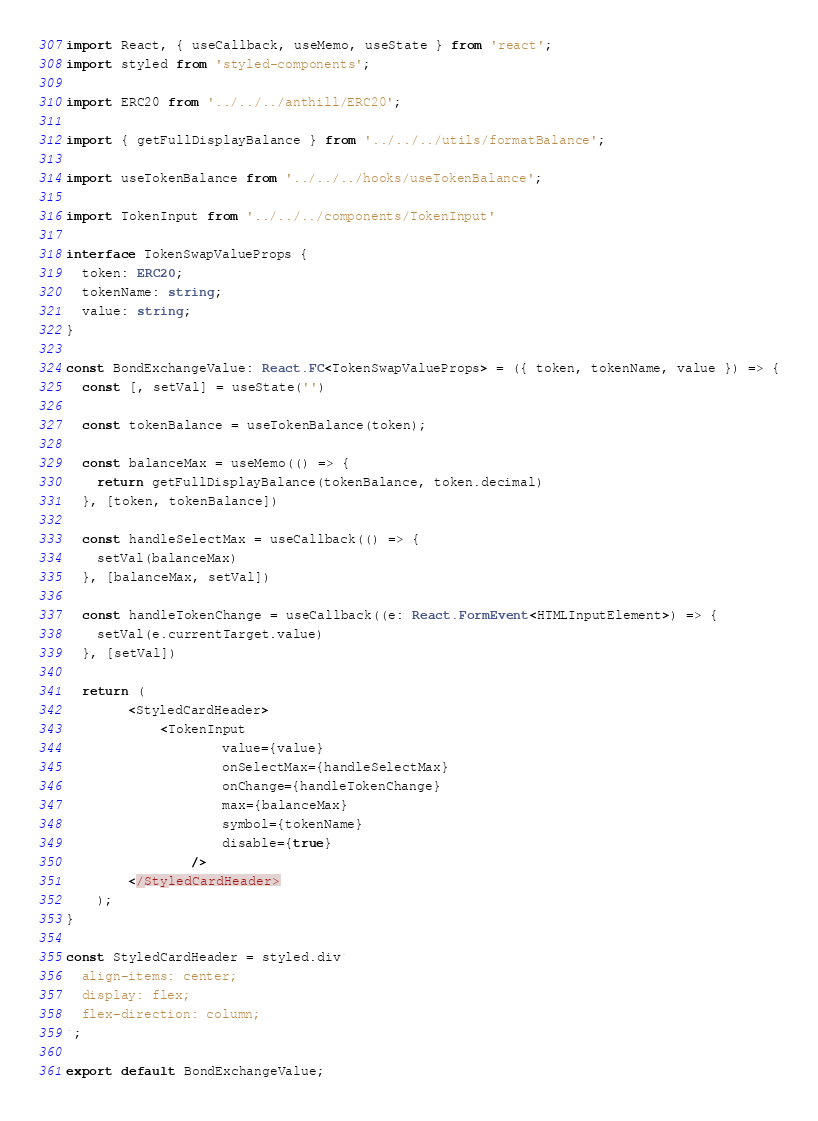<code> <loc_0><loc_0><loc_500><loc_500><_TypeScript_>import React, { useCallback, useMemo, useState } from 'react';
import styled from 'styled-components';

import ERC20 from '../../../anthill/ERC20';

import { getFullDisplayBalance } from '../../../utils/formatBalance';

import useTokenBalance from '../../../hooks/useTokenBalance';

import TokenInput from '../../../components/TokenInput'

interface TokenSwapValueProps {
  token: ERC20;
  tokenName: string;
  value: string;
}

const BondExchangeValue: React.FC<TokenSwapValueProps> = ({ token, tokenName, value }) => {
  const [, setVal] = useState('')

  const tokenBalance = useTokenBalance(token);
    
  const balanceMax = useMemo(() => {
    return getFullDisplayBalance(tokenBalance, token.decimal)
  }, [token, tokenBalance])

  const handleSelectMax = useCallback(() => {
    setVal(balanceMax)
  }, [balanceMax, setVal])

  const handleTokenChange = useCallback((e: React.FormEvent<HTMLInputElement>) => {
    setVal(e.currentTarget.value)
  }, [setVal])

  return (
        <StyledCardHeader>
            <TokenInput
                    value={value}
                    onSelectMax={handleSelectMax}
                    onChange={handleTokenChange}
                    max={balanceMax}
                    symbol={tokenName}
                    disable={true}
                />
        </StyledCardHeader>
    );
}

const StyledCardHeader = styled.div`
  align-items: center;
  display: flex;
  flex-direction: column;
`;

export default BondExchangeValue;
</code> 